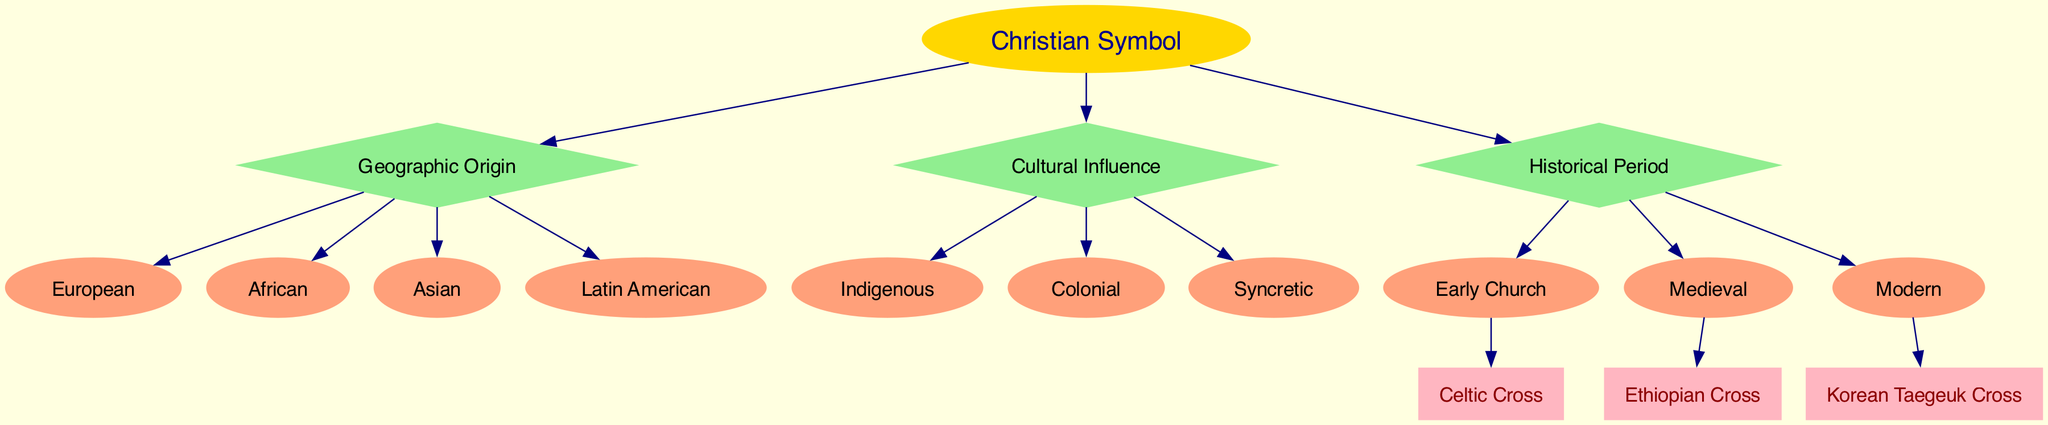What is the root of the decision tree? The diagram indicates that the root node is labeled "Christian Symbol," which serves as the starting point for classification.
Answer: Christian Symbol How many features are present in the decision tree? The diagram lists three features: Geographic Origin, Cultural Influence, and Historical Period, indicating there are a total of three features used for classification.
Answer: 3 What is one branch under the feature "Geographic Origin"? According to the diagram, one of the branches originating from the "Geographic Origin" feature is "European," showing a specific geographical classification option.
Answer: European Which feature has the branch "Indigenous"? The branch "Indigenous" is connected to the feature "Cultural Influence," depicting a classification based on cultural factors alongside others.
Answer: Cultural Influence How many outcomes are resulted from the decision tree? The diagram illustrates eight unique outcomes listed as Christian symbols, representing the final classifications derived from the decision-making process.
Answer: 8 If the input is "Asian" for Geographic Origin and "Syncretic" for Cultural Influence, which outcome is reached? Tracing the branches, the "Asian" input leads to the next decision node, and combined with "Syncretic," the final outcome aligns with the symbol that corresponds to those characteristics. Thus, considering the flow, the first would be the "Korean Taegeuk Cross."
Answer: Korean Taegeuk Cross What is the last feature in the decision tree? The final feature at the bottom of the decision flow is "Historical Period," which is the last consideration in determining the Christian symbol outcome after the others.
Answer: Historical Period How many branches are associated with the feature "Historical Period"? The feature "Historical Period" has three branches: Early Church, Medieval, and Modern, conveying a detailed categorization by time.
Answer: 3 Name the outcome linked to the "African" origin and "Early Church" period. The flow tracing from "African" to the last decision node drops down to the outcome leading to the symbol fitting those criteria; thus, it points to the "Ethiopian Cross."
Answer: Ethiopian Cross 